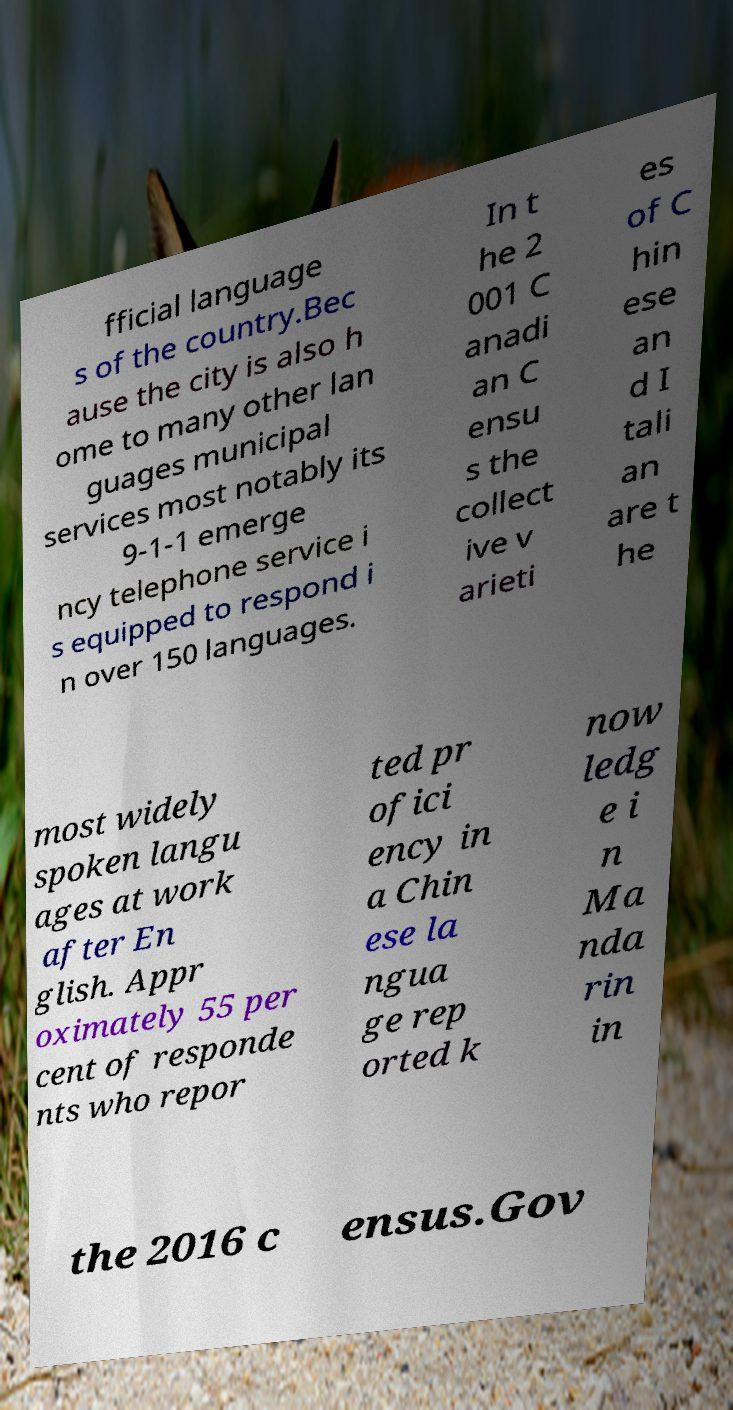Can you read and provide the text displayed in the image?This photo seems to have some interesting text. Can you extract and type it out for me? fficial language s of the country.Bec ause the city is also h ome to many other lan guages municipal services most notably its 9-1-1 emerge ncy telephone service i s equipped to respond i n over 150 languages. In t he 2 001 C anadi an C ensu s the collect ive v arieti es of C hin ese an d I tali an are t he most widely spoken langu ages at work after En glish. Appr oximately 55 per cent of responde nts who repor ted pr ofici ency in a Chin ese la ngua ge rep orted k now ledg e i n Ma nda rin in the 2016 c ensus.Gov 